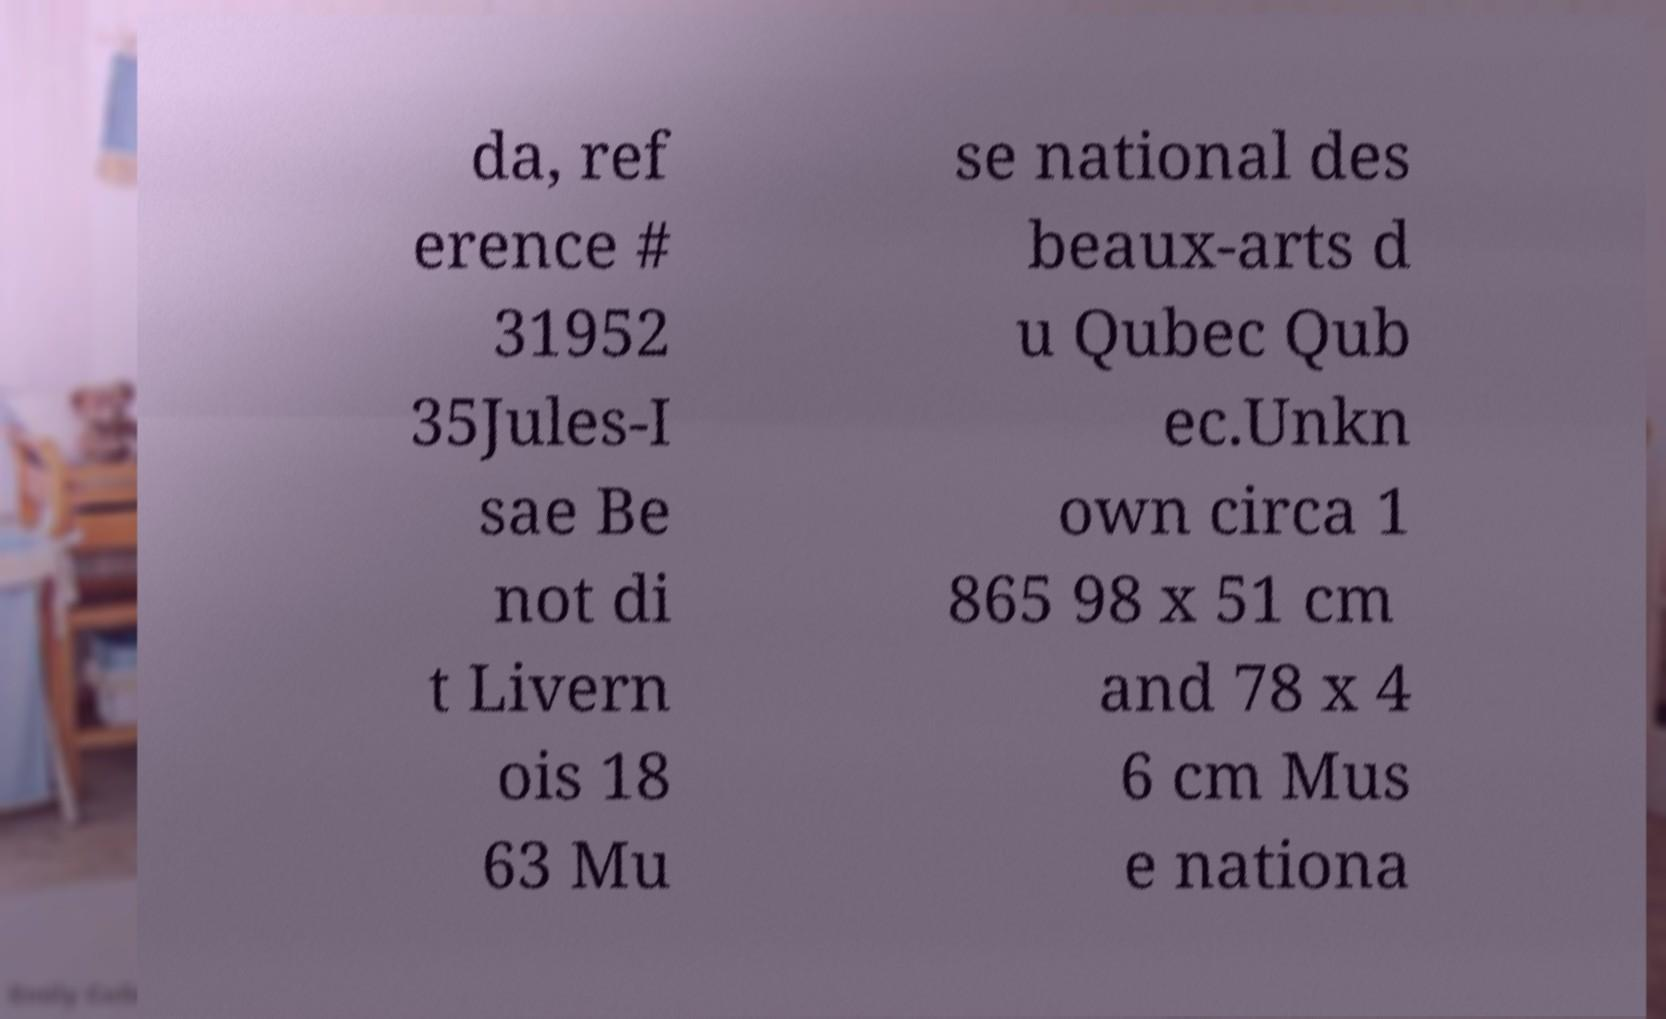I need the written content from this picture converted into text. Can you do that? da, ref erence # 31952 35Jules-I sae Be not di t Livern ois 18 63 Mu se national des beaux-arts d u Qubec Qub ec.Unkn own circa 1 865 98 x 51 cm and 78 x 4 6 cm Mus e nationa 